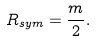Convert formula to latex. <formula><loc_0><loc_0><loc_500><loc_500>R _ { s y m } = \frac { m } { 2 } .</formula> 